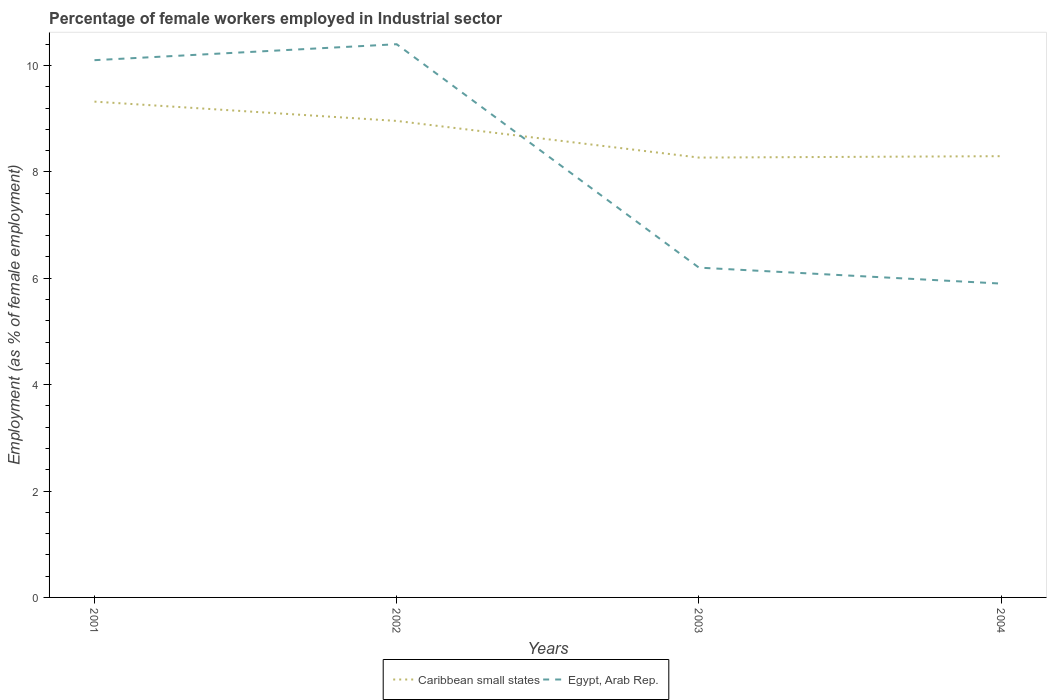Is the number of lines equal to the number of legend labels?
Your answer should be very brief. Yes. Across all years, what is the maximum percentage of females employed in Industrial sector in Caribbean small states?
Offer a very short reply. 8.27. What is the total percentage of females employed in Industrial sector in Egypt, Arab Rep. in the graph?
Offer a terse response. 4.5. What is the difference between the highest and the second highest percentage of females employed in Industrial sector in Caribbean small states?
Offer a terse response. 1.05. What is the difference between two consecutive major ticks on the Y-axis?
Provide a succinct answer. 2. Does the graph contain any zero values?
Your response must be concise. No. Where does the legend appear in the graph?
Keep it short and to the point. Bottom center. How are the legend labels stacked?
Your answer should be very brief. Horizontal. What is the title of the graph?
Make the answer very short. Percentage of female workers employed in Industrial sector. What is the label or title of the X-axis?
Make the answer very short. Years. What is the label or title of the Y-axis?
Your answer should be very brief. Employment (as % of female employment). What is the Employment (as % of female employment) of Caribbean small states in 2001?
Keep it short and to the point. 9.32. What is the Employment (as % of female employment) of Egypt, Arab Rep. in 2001?
Offer a very short reply. 10.1. What is the Employment (as % of female employment) in Caribbean small states in 2002?
Provide a succinct answer. 8.96. What is the Employment (as % of female employment) in Egypt, Arab Rep. in 2002?
Offer a very short reply. 10.4. What is the Employment (as % of female employment) of Caribbean small states in 2003?
Provide a short and direct response. 8.27. What is the Employment (as % of female employment) in Egypt, Arab Rep. in 2003?
Offer a very short reply. 6.2. What is the Employment (as % of female employment) of Caribbean small states in 2004?
Give a very brief answer. 8.3. What is the Employment (as % of female employment) in Egypt, Arab Rep. in 2004?
Your answer should be very brief. 5.9. Across all years, what is the maximum Employment (as % of female employment) of Caribbean small states?
Your response must be concise. 9.32. Across all years, what is the maximum Employment (as % of female employment) in Egypt, Arab Rep.?
Your response must be concise. 10.4. Across all years, what is the minimum Employment (as % of female employment) of Caribbean small states?
Ensure brevity in your answer.  8.27. Across all years, what is the minimum Employment (as % of female employment) in Egypt, Arab Rep.?
Your response must be concise. 5.9. What is the total Employment (as % of female employment) of Caribbean small states in the graph?
Your answer should be very brief. 34.84. What is the total Employment (as % of female employment) in Egypt, Arab Rep. in the graph?
Provide a succinct answer. 32.6. What is the difference between the Employment (as % of female employment) of Caribbean small states in 2001 and that in 2002?
Keep it short and to the point. 0.36. What is the difference between the Employment (as % of female employment) of Egypt, Arab Rep. in 2001 and that in 2002?
Ensure brevity in your answer.  -0.3. What is the difference between the Employment (as % of female employment) in Caribbean small states in 2001 and that in 2003?
Provide a succinct answer. 1.05. What is the difference between the Employment (as % of female employment) in Egypt, Arab Rep. in 2001 and that in 2003?
Keep it short and to the point. 3.9. What is the difference between the Employment (as % of female employment) in Caribbean small states in 2001 and that in 2004?
Your answer should be compact. 1.03. What is the difference between the Employment (as % of female employment) of Egypt, Arab Rep. in 2001 and that in 2004?
Provide a short and direct response. 4.2. What is the difference between the Employment (as % of female employment) in Caribbean small states in 2002 and that in 2003?
Make the answer very short. 0.69. What is the difference between the Employment (as % of female employment) in Egypt, Arab Rep. in 2002 and that in 2003?
Make the answer very short. 4.2. What is the difference between the Employment (as % of female employment) in Caribbean small states in 2002 and that in 2004?
Your answer should be compact. 0.66. What is the difference between the Employment (as % of female employment) of Caribbean small states in 2003 and that in 2004?
Provide a short and direct response. -0.03. What is the difference between the Employment (as % of female employment) in Caribbean small states in 2001 and the Employment (as % of female employment) in Egypt, Arab Rep. in 2002?
Provide a short and direct response. -1.08. What is the difference between the Employment (as % of female employment) of Caribbean small states in 2001 and the Employment (as % of female employment) of Egypt, Arab Rep. in 2003?
Provide a short and direct response. 3.12. What is the difference between the Employment (as % of female employment) of Caribbean small states in 2001 and the Employment (as % of female employment) of Egypt, Arab Rep. in 2004?
Provide a succinct answer. 3.42. What is the difference between the Employment (as % of female employment) in Caribbean small states in 2002 and the Employment (as % of female employment) in Egypt, Arab Rep. in 2003?
Provide a short and direct response. 2.76. What is the difference between the Employment (as % of female employment) in Caribbean small states in 2002 and the Employment (as % of female employment) in Egypt, Arab Rep. in 2004?
Offer a terse response. 3.06. What is the difference between the Employment (as % of female employment) of Caribbean small states in 2003 and the Employment (as % of female employment) of Egypt, Arab Rep. in 2004?
Your answer should be very brief. 2.37. What is the average Employment (as % of female employment) in Caribbean small states per year?
Your response must be concise. 8.71. What is the average Employment (as % of female employment) in Egypt, Arab Rep. per year?
Offer a very short reply. 8.15. In the year 2001, what is the difference between the Employment (as % of female employment) of Caribbean small states and Employment (as % of female employment) of Egypt, Arab Rep.?
Your response must be concise. -0.78. In the year 2002, what is the difference between the Employment (as % of female employment) of Caribbean small states and Employment (as % of female employment) of Egypt, Arab Rep.?
Provide a succinct answer. -1.44. In the year 2003, what is the difference between the Employment (as % of female employment) of Caribbean small states and Employment (as % of female employment) of Egypt, Arab Rep.?
Provide a short and direct response. 2.07. In the year 2004, what is the difference between the Employment (as % of female employment) in Caribbean small states and Employment (as % of female employment) in Egypt, Arab Rep.?
Provide a short and direct response. 2.4. What is the ratio of the Employment (as % of female employment) in Caribbean small states in 2001 to that in 2002?
Provide a short and direct response. 1.04. What is the ratio of the Employment (as % of female employment) of Egypt, Arab Rep. in 2001 to that in 2002?
Give a very brief answer. 0.97. What is the ratio of the Employment (as % of female employment) of Caribbean small states in 2001 to that in 2003?
Offer a terse response. 1.13. What is the ratio of the Employment (as % of female employment) of Egypt, Arab Rep. in 2001 to that in 2003?
Provide a succinct answer. 1.63. What is the ratio of the Employment (as % of female employment) in Caribbean small states in 2001 to that in 2004?
Make the answer very short. 1.12. What is the ratio of the Employment (as % of female employment) in Egypt, Arab Rep. in 2001 to that in 2004?
Provide a short and direct response. 1.71. What is the ratio of the Employment (as % of female employment) of Caribbean small states in 2002 to that in 2003?
Offer a terse response. 1.08. What is the ratio of the Employment (as % of female employment) of Egypt, Arab Rep. in 2002 to that in 2003?
Keep it short and to the point. 1.68. What is the ratio of the Employment (as % of female employment) in Caribbean small states in 2002 to that in 2004?
Offer a terse response. 1.08. What is the ratio of the Employment (as % of female employment) in Egypt, Arab Rep. in 2002 to that in 2004?
Keep it short and to the point. 1.76. What is the ratio of the Employment (as % of female employment) in Caribbean small states in 2003 to that in 2004?
Your response must be concise. 1. What is the ratio of the Employment (as % of female employment) of Egypt, Arab Rep. in 2003 to that in 2004?
Provide a short and direct response. 1.05. What is the difference between the highest and the second highest Employment (as % of female employment) of Caribbean small states?
Make the answer very short. 0.36. What is the difference between the highest and the lowest Employment (as % of female employment) of Caribbean small states?
Your answer should be compact. 1.05. What is the difference between the highest and the lowest Employment (as % of female employment) in Egypt, Arab Rep.?
Give a very brief answer. 4.5. 